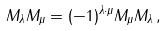<formula> <loc_0><loc_0><loc_500><loc_500>M _ { \lambda } M _ { \mu } = ( - 1 ) ^ { \lambda \cdot \mu } M _ { \mu } M _ { \lambda } \, ,</formula> 